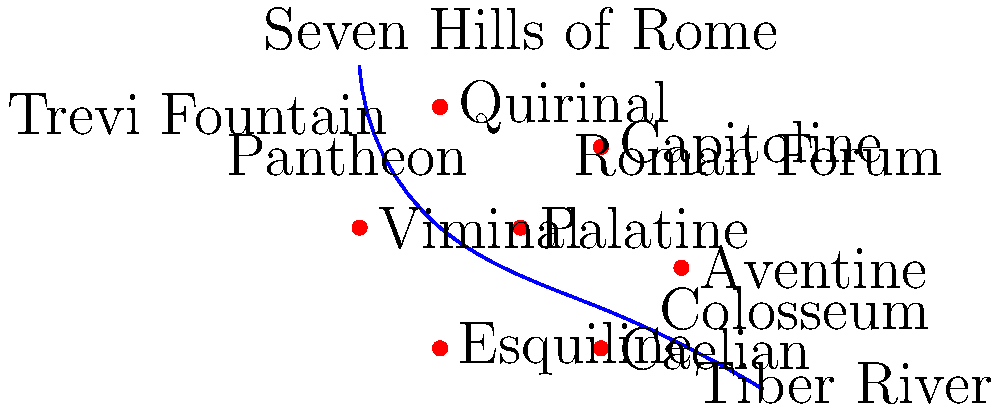As an influencer familiar with Rome's historical attractions, identify which of the Seven Hills is not directly adjacent to the cluster formed by the Palatine, Capitoline, and Quirinal hills in this simplified map of ancient Rome. To answer this question, let's follow these steps:

1. Locate the Palatine, Capitoline, and Quirinal hills on the map:
   - Palatine: Central hill
   - Capitoline: Hill to the northwest of Palatine
   - Quirinal: Hill to the northeast of Palatine

2. Identify the cluster formed by these three hills.

3. Examine the remaining hills and their positions relative to this cluster:
   - Aventine: Southeast of Palatine
   - Viminal: East of Quirinal
   - Esquiline: Southeast of Quirinal
   - Caelian: South of Palatine

4. Determine which hill is not directly adjacent to the cluster:
   - Aventine, Viminal, Esquiline, and Caelian are all touching or very close to at least one of the hills in the cluster.
   - The Aventine hill, located to the southeast, is the farthest from the cluster and does not directly touch any of the three hills forming the cluster.

Therefore, the Aventine hill is not directly adjacent to the cluster formed by the Palatine, Capitoline, and Quirinal hills.
Answer: Aventine 